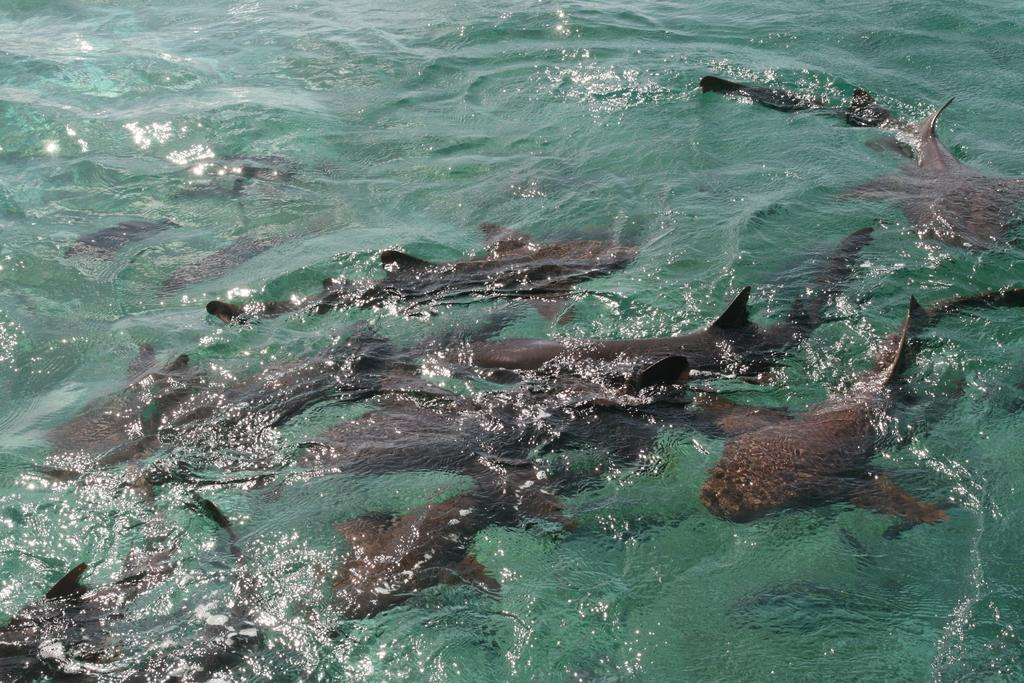What type of animals can be seen in the image? There are fishes in the image. Where are the fishes located? The fishes are underwater. What is the primary element in which the fishes are situated? There is water visible in the image, and the fishes are underwater. What type of chin can be seen on the fishes in the image? Fishes do not have chins, so there is no chin visible on the fishes in the image. 